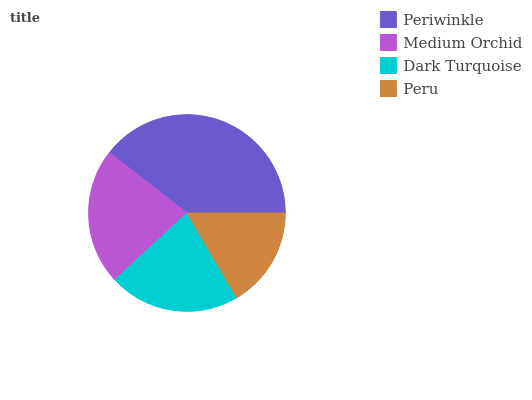Is Peru the minimum?
Answer yes or no. Yes. Is Periwinkle the maximum?
Answer yes or no. Yes. Is Medium Orchid the minimum?
Answer yes or no. No. Is Medium Orchid the maximum?
Answer yes or no. No. Is Periwinkle greater than Medium Orchid?
Answer yes or no. Yes. Is Medium Orchid less than Periwinkle?
Answer yes or no. Yes. Is Medium Orchid greater than Periwinkle?
Answer yes or no. No. Is Periwinkle less than Medium Orchid?
Answer yes or no. No. Is Medium Orchid the high median?
Answer yes or no. Yes. Is Dark Turquoise the low median?
Answer yes or no. Yes. Is Periwinkle the high median?
Answer yes or no. No. Is Medium Orchid the low median?
Answer yes or no. No. 